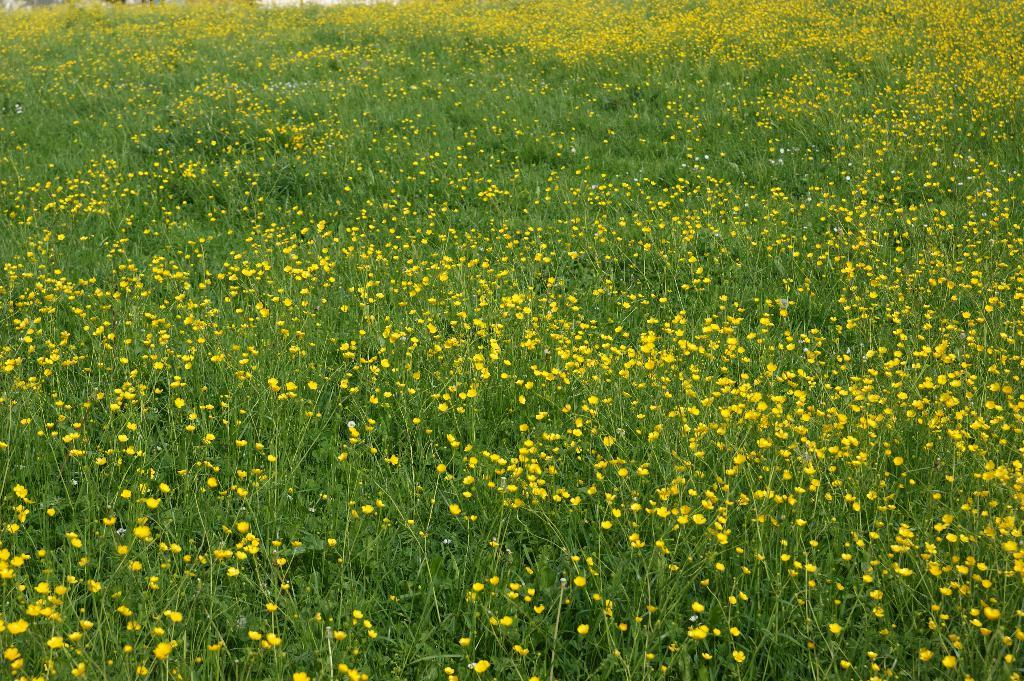What is the main subject of the image? The main subject of the image is a group of plants. What can be observed about the plants in the image? The plants have flowers. How many pets are visible in the image? There are no pets visible in the image; it features a group of plants with flowers. What type of bun is being prepared in the image? There is no bun or any indication of food preparation in the image. 